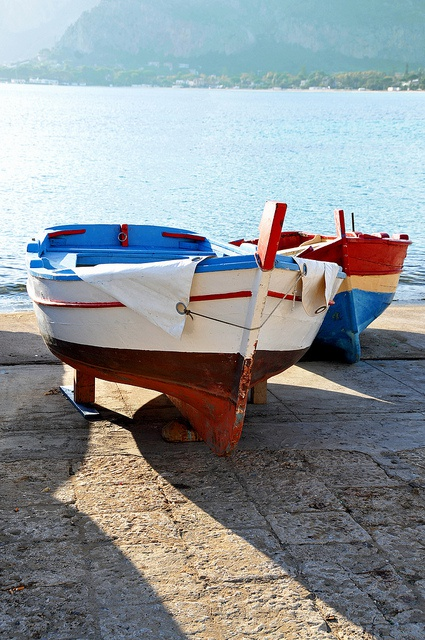Describe the objects in this image and their specific colors. I can see boat in white, darkgray, black, and maroon tones and boat in white, maroon, navy, and blue tones in this image. 